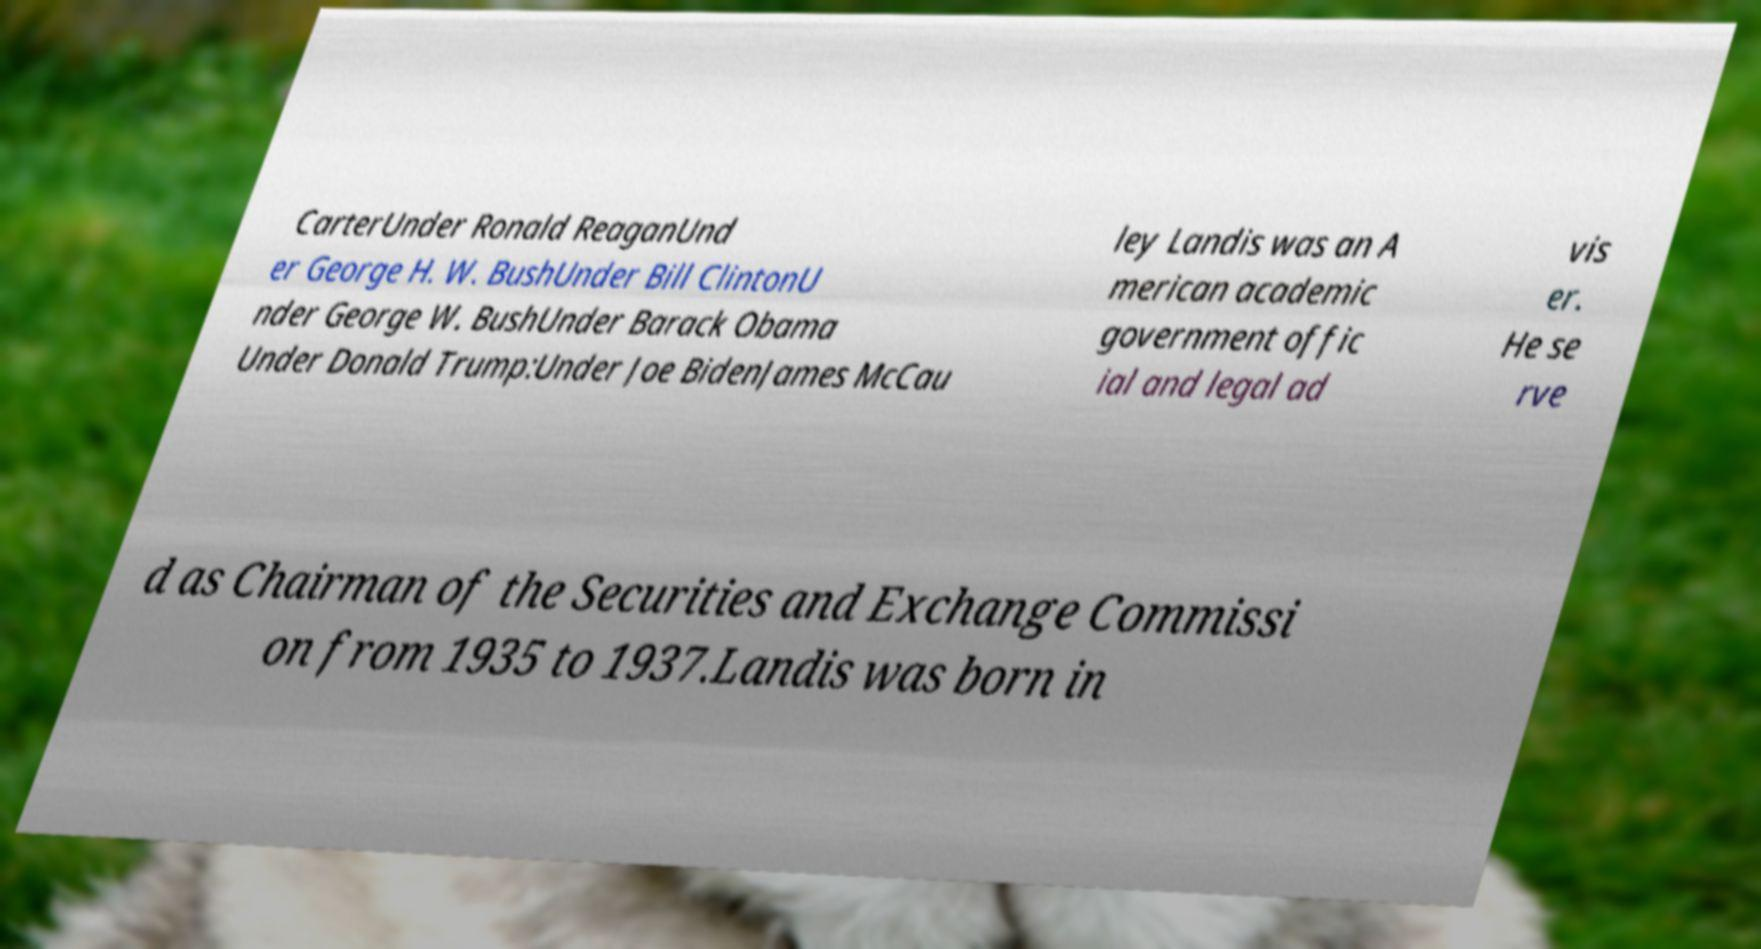For documentation purposes, I need the text within this image transcribed. Could you provide that? CarterUnder Ronald ReaganUnd er George H. W. BushUnder Bill ClintonU nder George W. BushUnder Barack Obama Under Donald Trump:Under Joe BidenJames McCau ley Landis was an A merican academic government offic ial and legal ad vis er. He se rve d as Chairman of the Securities and Exchange Commissi on from 1935 to 1937.Landis was born in 